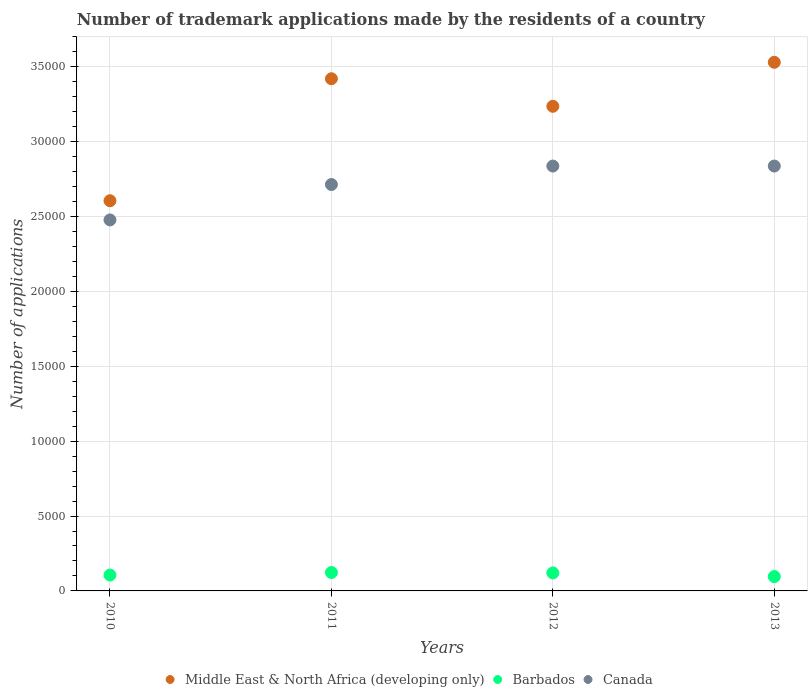How many different coloured dotlines are there?
Provide a short and direct response. 3. What is the number of trademark applications made by the residents in Canada in 2013?
Make the answer very short. 2.84e+04. Across all years, what is the maximum number of trademark applications made by the residents in Canada?
Your answer should be very brief. 2.84e+04. Across all years, what is the minimum number of trademark applications made by the residents in Barbados?
Keep it short and to the point. 958. In which year was the number of trademark applications made by the residents in Middle East & North Africa (developing only) maximum?
Your response must be concise. 2013. What is the total number of trademark applications made by the residents in Middle East & North Africa (developing only) in the graph?
Provide a succinct answer. 1.28e+05. What is the difference between the number of trademark applications made by the residents in Middle East & North Africa (developing only) in 2010 and that in 2011?
Make the answer very short. -8146. What is the difference between the number of trademark applications made by the residents in Canada in 2013 and the number of trademark applications made by the residents in Middle East & North Africa (developing only) in 2012?
Ensure brevity in your answer.  -3989. What is the average number of trademark applications made by the residents in Canada per year?
Give a very brief answer. 2.72e+04. In the year 2011, what is the difference between the number of trademark applications made by the residents in Barbados and number of trademark applications made by the residents in Middle East & North Africa (developing only)?
Your answer should be very brief. -3.30e+04. What is the ratio of the number of trademark applications made by the residents in Canada in 2012 to that in 2013?
Ensure brevity in your answer.  1. Is the difference between the number of trademark applications made by the residents in Barbados in 2010 and 2012 greater than the difference between the number of trademark applications made by the residents in Middle East & North Africa (developing only) in 2010 and 2012?
Keep it short and to the point. Yes. What is the difference between the highest and the lowest number of trademark applications made by the residents in Barbados?
Give a very brief answer. 271. In how many years, is the number of trademark applications made by the residents in Canada greater than the average number of trademark applications made by the residents in Canada taken over all years?
Provide a short and direct response. 2. Is it the case that in every year, the sum of the number of trademark applications made by the residents in Barbados and number of trademark applications made by the residents in Middle East & North Africa (developing only)  is greater than the number of trademark applications made by the residents in Canada?
Your answer should be compact. Yes. How many dotlines are there?
Your answer should be very brief. 3. How many years are there in the graph?
Your response must be concise. 4. Are the values on the major ticks of Y-axis written in scientific E-notation?
Provide a short and direct response. No. Does the graph contain any zero values?
Provide a short and direct response. No. Does the graph contain grids?
Ensure brevity in your answer.  Yes. How many legend labels are there?
Provide a short and direct response. 3. How are the legend labels stacked?
Offer a very short reply. Horizontal. What is the title of the graph?
Keep it short and to the point. Number of trademark applications made by the residents of a country. What is the label or title of the Y-axis?
Provide a short and direct response. Number of applications. What is the Number of applications of Middle East & North Africa (developing only) in 2010?
Give a very brief answer. 2.61e+04. What is the Number of applications in Barbados in 2010?
Ensure brevity in your answer.  1061. What is the Number of applications of Canada in 2010?
Your response must be concise. 2.48e+04. What is the Number of applications in Middle East & North Africa (developing only) in 2011?
Offer a terse response. 3.42e+04. What is the Number of applications in Barbados in 2011?
Your answer should be very brief. 1229. What is the Number of applications of Canada in 2011?
Provide a succinct answer. 2.71e+04. What is the Number of applications of Middle East & North Africa (developing only) in 2012?
Your response must be concise. 3.24e+04. What is the Number of applications in Barbados in 2012?
Your response must be concise. 1202. What is the Number of applications in Canada in 2012?
Provide a succinct answer. 2.84e+04. What is the Number of applications of Middle East & North Africa (developing only) in 2013?
Make the answer very short. 3.53e+04. What is the Number of applications in Barbados in 2013?
Make the answer very short. 958. What is the Number of applications of Canada in 2013?
Ensure brevity in your answer.  2.84e+04. Across all years, what is the maximum Number of applications in Middle East & North Africa (developing only)?
Provide a short and direct response. 3.53e+04. Across all years, what is the maximum Number of applications in Barbados?
Offer a terse response. 1229. Across all years, what is the maximum Number of applications in Canada?
Give a very brief answer. 2.84e+04. Across all years, what is the minimum Number of applications in Middle East & North Africa (developing only)?
Provide a short and direct response. 2.61e+04. Across all years, what is the minimum Number of applications of Barbados?
Your response must be concise. 958. Across all years, what is the minimum Number of applications of Canada?
Give a very brief answer. 2.48e+04. What is the total Number of applications of Middle East & North Africa (developing only) in the graph?
Your response must be concise. 1.28e+05. What is the total Number of applications of Barbados in the graph?
Offer a very short reply. 4450. What is the total Number of applications in Canada in the graph?
Provide a succinct answer. 1.09e+05. What is the difference between the Number of applications of Middle East & North Africa (developing only) in 2010 and that in 2011?
Offer a terse response. -8146. What is the difference between the Number of applications of Barbados in 2010 and that in 2011?
Offer a very short reply. -168. What is the difference between the Number of applications in Canada in 2010 and that in 2011?
Provide a succinct answer. -2364. What is the difference between the Number of applications in Middle East & North Africa (developing only) in 2010 and that in 2012?
Provide a succinct answer. -6306. What is the difference between the Number of applications of Barbados in 2010 and that in 2012?
Give a very brief answer. -141. What is the difference between the Number of applications of Canada in 2010 and that in 2012?
Ensure brevity in your answer.  -3598. What is the difference between the Number of applications in Middle East & North Africa (developing only) in 2010 and that in 2013?
Give a very brief answer. -9244. What is the difference between the Number of applications in Barbados in 2010 and that in 2013?
Keep it short and to the point. 103. What is the difference between the Number of applications of Canada in 2010 and that in 2013?
Keep it short and to the point. -3599. What is the difference between the Number of applications in Middle East & North Africa (developing only) in 2011 and that in 2012?
Your answer should be compact. 1840. What is the difference between the Number of applications of Barbados in 2011 and that in 2012?
Your answer should be compact. 27. What is the difference between the Number of applications in Canada in 2011 and that in 2012?
Keep it short and to the point. -1234. What is the difference between the Number of applications in Middle East & North Africa (developing only) in 2011 and that in 2013?
Your response must be concise. -1098. What is the difference between the Number of applications in Barbados in 2011 and that in 2013?
Offer a very short reply. 271. What is the difference between the Number of applications of Canada in 2011 and that in 2013?
Make the answer very short. -1235. What is the difference between the Number of applications in Middle East & North Africa (developing only) in 2012 and that in 2013?
Your response must be concise. -2938. What is the difference between the Number of applications in Barbados in 2012 and that in 2013?
Your response must be concise. 244. What is the difference between the Number of applications of Canada in 2012 and that in 2013?
Your answer should be very brief. -1. What is the difference between the Number of applications of Middle East & North Africa (developing only) in 2010 and the Number of applications of Barbados in 2011?
Provide a short and direct response. 2.48e+04. What is the difference between the Number of applications of Middle East & North Africa (developing only) in 2010 and the Number of applications of Canada in 2011?
Offer a very short reply. -1082. What is the difference between the Number of applications of Barbados in 2010 and the Number of applications of Canada in 2011?
Ensure brevity in your answer.  -2.61e+04. What is the difference between the Number of applications of Middle East & North Africa (developing only) in 2010 and the Number of applications of Barbados in 2012?
Give a very brief answer. 2.49e+04. What is the difference between the Number of applications in Middle East & North Africa (developing only) in 2010 and the Number of applications in Canada in 2012?
Your response must be concise. -2316. What is the difference between the Number of applications of Barbados in 2010 and the Number of applications of Canada in 2012?
Offer a very short reply. -2.73e+04. What is the difference between the Number of applications in Middle East & North Africa (developing only) in 2010 and the Number of applications in Barbados in 2013?
Your answer should be compact. 2.51e+04. What is the difference between the Number of applications in Middle East & North Africa (developing only) in 2010 and the Number of applications in Canada in 2013?
Provide a succinct answer. -2317. What is the difference between the Number of applications of Barbados in 2010 and the Number of applications of Canada in 2013?
Your answer should be compact. -2.73e+04. What is the difference between the Number of applications of Middle East & North Africa (developing only) in 2011 and the Number of applications of Barbados in 2012?
Offer a very short reply. 3.30e+04. What is the difference between the Number of applications of Middle East & North Africa (developing only) in 2011 and the Number of applications of Canada in 2012?
Your answer should be very brief. 5830. What is the difference between the Number of applications in Barbados in 2011 and the Number of applications in Canada in 2012?
Your answer should be very brief. -2.71e+04. What is the difference between the Number of applications in Middle East & North Africa (developing only) in 2011 and the Number of applications in Barbados in 2013?
Your response must be concise. 3.32e+04. What is the difference between the Number of applications in Middle East & North Africa (developing only) in 2011 and the Number of applications in Canada in 2013?
Keep it short and to the point. 5829. What is the difference between the Number of applications in Barbados in 2011 and the Number of applications in Canada in 2013?
Offer a very short reply. -2.71e+04. What is the difference between the Number of applications in Middle East & North Africa (developing only) in 2012 and the Number of applications in Barbados in 2013?
Your answer should be very brief. 3.14e+04. What is the difference between the Number of applications in Middle East & North Africa (developing only) in 2012 and the Number of applications in Canada in 2013?
Provide a succinct answer. 3989. What is the difference between the Number of applications in Barbados in 2012 and the Number of applications in Canada in 2013?
Your response must be concise. -2.72e+04. What is the average Number of applications in Middle East & North Africa (developing only) per year?
Keep it short and to the point. 3.20e+04. What is the average Number of applications in Barbados per year?
Offer a very short reply. 1112.5. What is the average Number of applications of Canada per year?
Provide a short and direct response. 2.72e+04. In the year 2010, what is the difference between the Number of applications in Middle East & North Africa (developing only) and Number of applications in Barbados?
Provide a succinct answer. 2.50e+04. In the year 2010, what is the difference between the Number of applications of Middle East & North Africa (developing only) and Number of applications of Canada?
Provide a short and direct response. 1282. In the year 2010, what is the difference between the Number of applications of Barbados and Number of applications of Canada?
Offer a terse response. -2.37e+04. In the year 2011, what is the difference between the Number of applications in Middle East & North Africa (developing only) and Number of applications in Barbados?
Keep it short and to the point. 3.30e+04. In the year 2011, what is the difference between the Number of applications in Middle East & North Africa (developing only) and Number of applications in Canada?
Offer a very short reply. 7064. In the year 2011, what is the difference between the Number of applications in Barbados and Number of applications in Canada?
Offer a terse response. -2.59e+04. In the year 2012, what is the difference between the Number of applications in Middle East & North Africa (developing only) and Number of applications in Barbados?
Provide a succinct answer. 3.12e+04. In the year 2012, what is the difference between the Number of applications in Middle East & North Africa (developing only) and Number of applications in Canada?
Give a very brief answer. 3990. In the year 2012, what is the difference between the Number of applications of Barbados and Number of applications of Canada?
Keep it short and to the point. -2.72e+04. In the year 2013, what is the difference between the Number of applications of Middle East & North Africa (developing only) and Number of applications of Barbados?
Ensure brevity in your answer.  3.43e+04. In the year 2013, what is the difference between the Number of applications in Middle East & North Africa (developing only) and Number of applications in Canada?
Offer a very short reply. 6927. In the year 2013, what is the difference between the Number of applications of Barbados and Number of applications of Canada?
Your response must be concise. -2.74e+04. What is the ratio of the Number of applications in Middle East & North Africa (developing only) in 2010 to that in 2011?
Ensure brevity in your answer.  0.76. What is the ratio of the Number of applications in Barbados in 2010 to that in 2011?
Your answer should be compact. 0.86. What is the ratio of the Number of applications of Canada in 2010 to that in 2011?
Your response must be concise. 0.91. What is the ratio of the Number of applications in Middle East & North Africa (developing only) in 2010 to that in 2012?
Make the answer very short. 0.81. What is the ratio of the Number of applications in Barbados in 2010 to that in 2012?
Offer a very short reply. 0.88. What is the ratio of the Number of applications in Canada in 2010 to that in 2012?
Provide a succinct answer. 0.87. What is the ratio of the Number of applications in Middle East & North Africa (developing only) in 2010 to that in 2013?
Provide a short and direct response. 0.74. What is the ratio of the Number of applications of Barbados in 2010 to that in 2013?
Your answer should be compact. 1.11. What is the ratio of the Number of applications in Canada in 2010 to that in 2013?
Ensure brevity in your answer.  0.87. What is the ratio of the Number of applications of Middle East & North Africa (developing only) in 2011 to that in 2012?
Keep it short and to the point. 1.06. What is the ratio of the Number of applications in Barbados in 2011 to that in 2012?
Ensure brevity in your answer.  1.02. What is the ratio of the Number of applications in Canada in 2011 to that in 2012?
Your response must be concise. 0.96. What is the ratio of the Number of applications in Middle East & North Africa (developing only) in 2011 to that in 2013?
Keep it short and to the point. 0.97. What is the ratio of the Number of applications in Barbados in 2011 to that in 2013?
Provide a succinct answer. 1.28. What is the ratio of the Number of applications of Canada in 2011 to that in 2013?
Give a very brief answer. 0.96. What is the ratio of the Number of applications in Middle East & North Africa (developing only) in 2012 to that in 2013?
Keep it short and to the point. 0.92. What is the ratio of the Number of applications of Barbados in 2012 to that in 2013?
Your answer should be compact. 1.25. What is the ratio of the Number of applications of Canada in 2012 to that in 2013?
Ensure brevity in your answer.  1. What is the difference between the highest and the second highest Number of applications of Middle East & North Africa (developing only)?
Offer a terse response. 1098. What is the difference between the highest and the lowest Number of applications in Middle East & North Africa (developing only)?
Keep it short and to the point. 9244. What is the difference between the highest and the lowest Number of applications in Barbados?
Make the answer very short. 271. What is the difference between the highest and the lowest Number of applications in Canada?
Your response must be concise. 3599. 